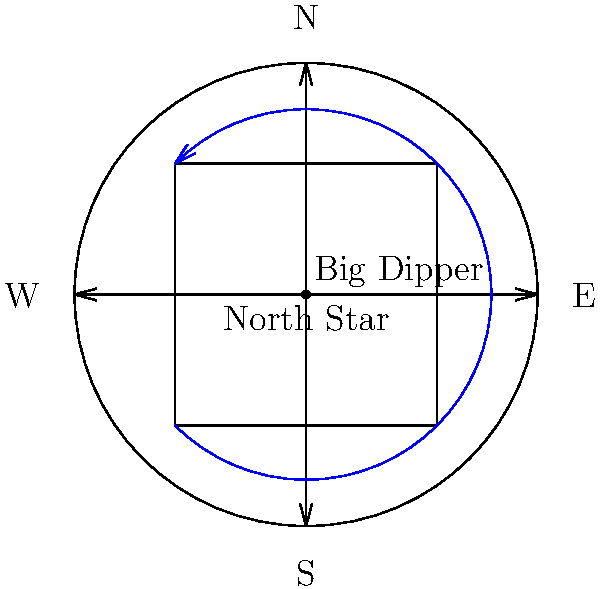As a television producer for race broadcasts, you want to include an educational segment about celestial navigation. How would you explain the apparent rotation of constellations around the North Star throughout the night to viewers? To explain the apparent rotation of constellations around the North Star:

1. The North Star (Polaris) is located almost directly above Earth's northern axis of rotation.

2. As Earth rotates on its axis, the North Star appears to remain stationary in the night sky.

3. Other stars and constellations appear to rotate around the North Star due to Earth's rotation:
   a. They complete one full rotation every 24 hours (more precisely, 23 hours and 56 minutes).
   b. The rotation is counterclockwise when facing north in the Northern Hemisphere.

4. Using the Big Dipper as an example:
   a. It rotates around the North Star throughout the night.
   b. Its position relative to the North Star can be used to estimate time.

5. This apparent rotation is useful for navigation:
   a. The North Star's elevation above the horizon indicates the observer's latitude.
   b. The rotation of other stars can be used to determine direction and time.

6. In the Southern Hemisphere, stars appear to rotate around the South Celestial Pole, but there is no bright "South Star."

7. This concept can be related to racing by comparing it to cars moving around a fixed point on a circular track, emphasizing the importance of consistent motion and timing.
Answer: Earth's rotation causes constellations to appear to rotate counterclockwise around the stationary North Star every 24 hours. 